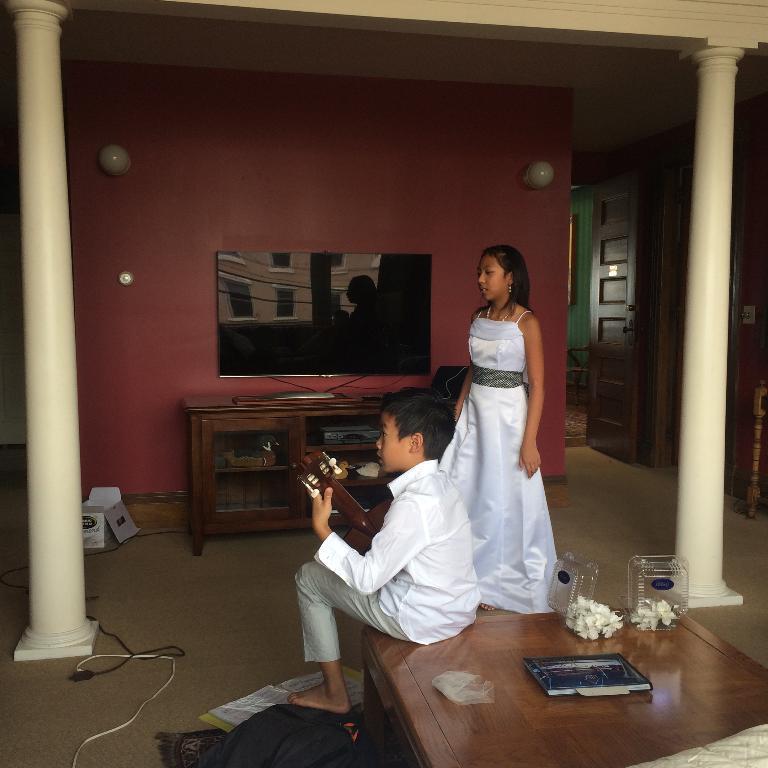In one or two sentences, can you explain what this image depicts? This is the women wearing white dress and standing. Here is the boy holding musical instrument and sitting on the table. This is the television which is placed on the television stand. these are the racks. These are the pillars. These are the bulbs attached to the wall. I can see some objects on the table. At background I can see the wooden door which is opened. this looks like a bag. This is a white cardboard box. 